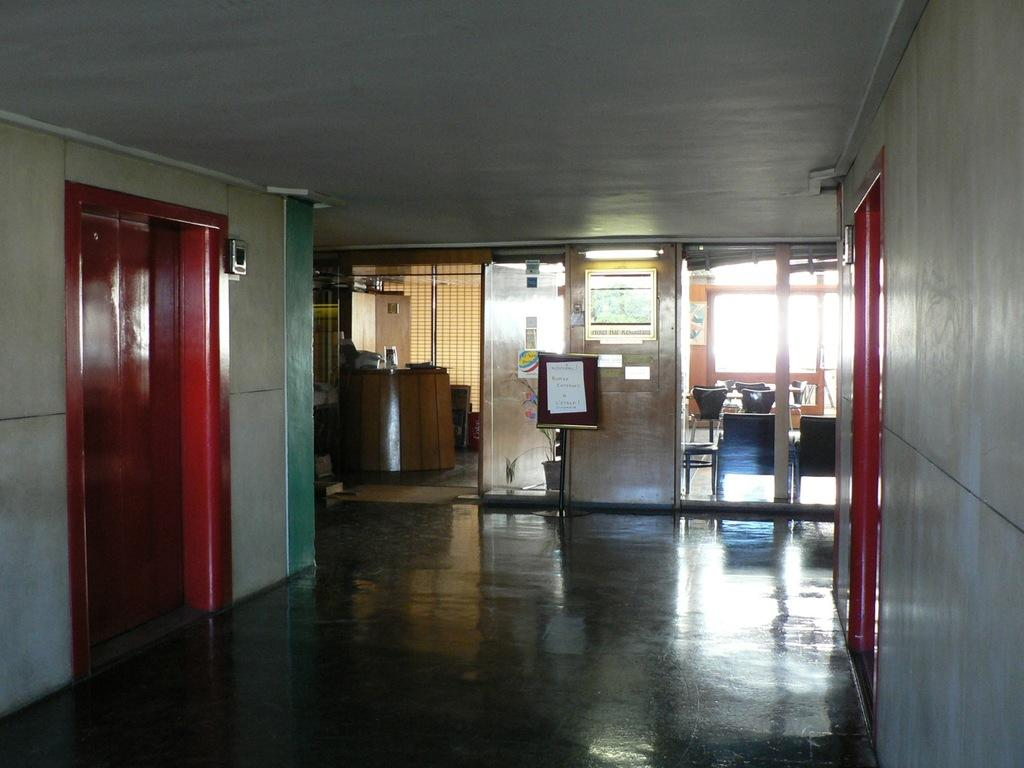What type of furniture can be seen in the image? There are chairs in the image. What type of wall decorations are present in the image? There are posters in the image. What type of openings are visible in the image? There are doors and windows in the image. What color is the wall in the image? The wall in the image is white. How would you describe the lighting in the image? The image is a little dark, but there is a light present. What type of barrier is visible in the image? There is a fence in the image. What type of cap is the person wearing in the image? There is no person wearing a cap in the image; the image does not depict any individuals. What design is featured on the fence in the image? The image does not show any specific design on the fence; it is a simple barrier. 